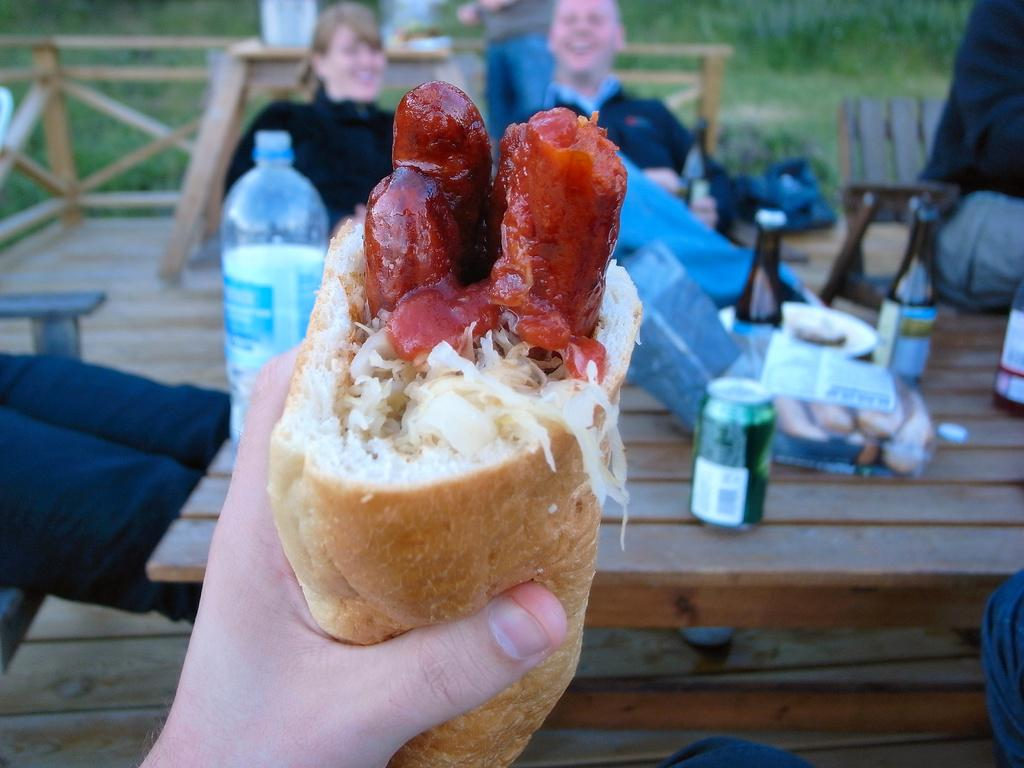What type of food is depicted in the image? There is a hot dog with meat in the image. Where is the food located? The food is on a table in the image. What else can be seen on the table? There are soft drink cans on the table. What can be observed in the background of the image? In the background, there are a man and a woman sitting on chairs. What type of collar can be seen on the hot dog in the image? There is no collar present on the hot dog in the image. Is there a pin holding the soft drink cans together in the image? There is no pin visible in the image; the soft drink cans are separate. 